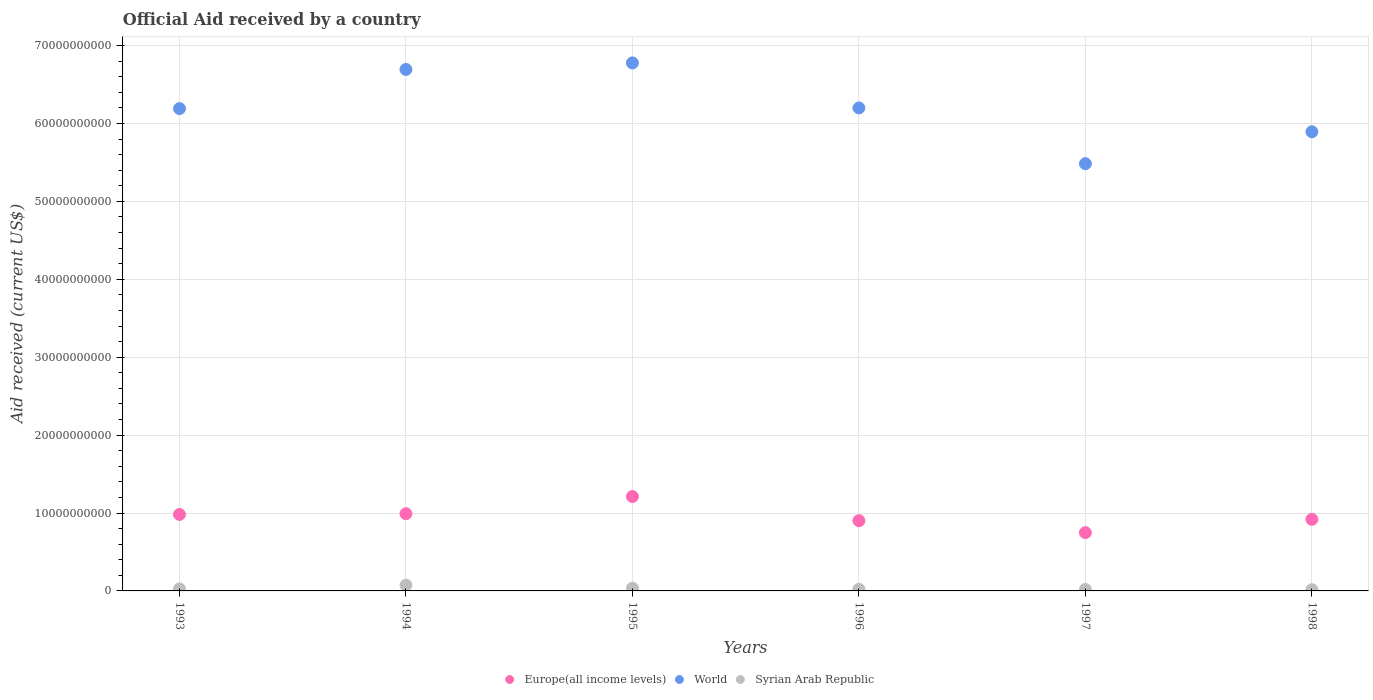What is the net official aid received in Europe(all income levels) in 1998?
Make the answer very short. 9.19e+09. Across all years, what is the maximum net official aid received in Syrian Arab Republic?
Your answer should be very brief. 7.44e+08. Across all years, what is the minimum net official aid received in World?
Give a very brief answer. 5.48e+1. What is the total net official aid received in Syrian Arab Republic in the graph?
Give a very brief answer. 1.93e+09. What is the difference between the net official aid received in World in 1993 and that in 1997?
Offer a very short reply. 7.07e+09. What is the difference between the net official aid received in Europe(all income levels) in 1993 and the net official aid received in World in 1994?
Your answer should be very brief. -5.71e+1. What is the average net official aid received in World per year?
Your answer should be very brief. 6.21e+1. In the year 1997, what is the difference between the net official aid received in World and net official aid received in Syrian Arab Republic?
Keep it short and to the point. 5.46e+1. What is the ratio of the net official aid received in World in 1993 to that in 1994?
Provide a short and direct response. 0.92. What is the difference between the highest and the second highest net official aid received in Syrian Arab Republic?
Provide a short and direct response. 3.88e+08. What is the difference between the highest and the lowest net official aid received in Europe(all income levels)?
Make the answer very short. 4.63e+09. Is it the case that in every year, the sum of the net official aid received in World and net official aid received in Europe(all income levels)  is greater than the net official aid received in Syrian Arab Republic?
Your answer should be compact. Yes. Does the net official aid received in Syrian Arab Republic monotonically increase over the years?
Your answer should be compact. No. Is the net official aid received in Europe(all income levels) strictly less than the net official aid received in World over the years?
Ensure brevity in your answer.  Yes. How many dotlines are there?
Offer a terse response. 3. What is the difference between two consecutive major ticks on the Y-axis?
Give a very brief answer. 1.00e+1. What is the title of the graph?
Your answer should be very brief. Official Aid received by a country. Does "Nigeria" appear as one of the legend labels in the graph?
Offer a very short reply. No. What is the label or title of the X-axis?
Ensure brevity in your answer.  Years. What is the label or title of the Y-axis?
Your answer should be compact. Aid received (current US$). What is the Aid received (current US$) of Europe(all income levels) in 1993?
Make the answer very short. 9.82e+09. What is the Aid received (current US$) of World in 1993?
Offer a very short reply. 6.19e+1. What is the Aid received (current US$) in Syrian Arab Republic in 1993?
Your response must be concise. 2.59e+08. What is the Aid received (current US$) of Europe(all income levels) in 1994?
Ensure brevity in your answer.  9.91e+09. What is the Aid received (current US$) in World in 1994?
Offer a terse response. 6.69e+1. What is the Aid received (current US$) in Syrian Arab Republic in 1994?
Your response must be concise. 7.44e+08. What is the Aid received (current US$) in Europe(all income levels) in 1995?
Keep it short and to the point. 1.21e+1. What is the Aid received (current US$) of World in 1995?
Ensure brevity in your answer.  6.78e+1. What is the Aid received (current US$) in Syrian Arab Republic in 1995?
Ensure brevity in your answer.  3.56e+08. What is the Aid received (current US$) of Europe(all income levels) in 1996?
Ensure brevity in your answer.  9.02e+09. What is the Aid received (current US$) in World in 1996?
Offer a terse response. 6.20e+1. What is the Aid received (current US$) in Syrian Arab Republic in 1996?
Provide a succinct answer. 2.16e+08. What is the Aid received (current US$) of Europe(all income levels) in 1997?
Ensure brevity in your answer.  7.48e+09. What is the Aid received (current US$) in World in 1997?
Keep it short and to the point. 5.48e+1. What is the Aid received (current US$) of Syrian Arab Republic in 1997?
Offer a terse response. 1.97e+08. What is the Aid received (current US$) in Europe(all income levels) in 1998?
Provide a succinct answer. 9.19e+09. What is the Aid received (current US$) of World in 1998?
Offer a very short reply. 5.89e+1. What is the Aid received (current US$) of Syrian Arab Republic in 1998?
Provide a succinct answer. 1.55e+08. Across all years, what is the maximum Aid received (current US$) in Europe(all income levels)?
Make the answer very short. 1.21e+1. Across all years, what is the maximum Aid received (current US$) of World?
Your response must be concise. 6.78e+1. Across all years, what is the maximum Aid received (current US$) in Syrian Arab Republic?
Offer a very short reply. 7.44e+08. Across all years, what is the minimum Aid received (current US$) in Europe(all income levels)?
Your answer should be compact. 7.48e+09. Across all years, what is the minimum Aid received (current US$) in World?
Provide a short and direct response. 5.48e+1. Across all years, what is the minimum Aid received (current US$) of Syrian Arab Republic?
Your response must be concise. 1.55e+08. What is the total Aid received (current US$) of Europe(all income levels) in the graph?
Provide a succinct answer. 5.75e+1. What is the total Aid received (current US$) in World in the graph?
Offer a terse response. 3.72e+11. What is the total Aid received (current US$) in Syrian Arab Republic in the graph?
Provide a succinct answer. 1.93e+09. What is the difference between the Aid received (current US$) in Europe(all income levels) in 1993 and that in 1994?
Offer a very short reply. -9.28e+07. What is the difference between the Aid received (current US$) of World in 1993 and that in 1994?
Make the answer very short. -5.03e+09. What is the difference between the Aid received (current US$) in Syrian Arab Republic in 1993 and that in 1994?
Give a very brief answer. -4.85e+08. What is the difference between the Aid received (current US$) in Europe(all income levels) in 1993 and that in 1995?
Your answer should be very brief. -2.29e+09. What is the difference between the Aid received (current US$) of World in 1993 and that in 1995?
Make the answer very short. -5.87e+09. What is the difference between the Aid received (current US$) in Syrian Arab Republic in 1993 and that in 1995?
Offer a very short reply. -9.74e+07. What is the difference between the Aid received (current US$) of Europe(all income levels) in 1993 and that in 1996?
Give a very brief answer. 8.02e+08. What is the difference between the Aid received (current US$) in World in 1993 and that in 1996?
Give a very brief answer. -9.08e+07. What is the difference between the Aid received (current US$) of Syrian Arab Republic in 1993 and that in 1996?
Your answer should be compact. 4.26e+07. What is the difference between the Aid received (current US$) in Europe(all income levels) in 1993 and that in 1997?
Your answer should be compact. 2.34e+09. What is the difference between the Aid received (current US$) in World in 1993 and that in 1997?
Keep it short and to the point. 7.07e+09. What is the difference between the Aid received (current US$) in Syrian Arab Republic in 1993 and that in 1997?
Offer a terse response. 6.19e+07. What is the difference between the Aid received (current US$) of Europe(all income levels) in 1993 and that in 1998?
Ensure brevity in your answer.  6.27e+08. What is the difference between the Aid received (current US$) of World in 1993 and that in 1998?
Your answer should be compact. 2.97e+09. What is the difference between the Aid received (current US$) of Syrian Arab Republic in 1993 and that in 1998?
Your response must be concise. 1.03e+08. What is the difference between the Aid received (current US$) of Europe(all income levels) in 1994 and that in 1995?
Provide a succinct answer. -2.20e+09. What is the difference between the Aid received (current US$) in World in 1994 and that in 1995?
Provide a succinct answer. -8.36e+08. What is the difference between the Aid received (current US$) of Syrian Arab Republic in 1994 and that in 1995?
Provide a short and direct response. 3.88e+08. What is the difference between the Aid received (current US$) in Europe(all income levels) in 1994 and that in 1996?
Give a very brief answer. 8.95e+08. What is the difference between the Aid received (current US$) in World in 1994 and that in 1996?
Make the answer very short. 4.94e+09. What is the difference between the Aid received (current US$) in Syrian Arab Republic in 1994 and that in 1996?
Your response must be concise. 5.28e+08. What is the difference between the Aid received (current US$) of Europe(all income levels) in 1994 and that in 1997?
Your answer should be very brief. 2.43e+09. What is the difference between the Aid received (current US$) in World in 1994 and that in 1997?
Ensure brevity in your answer.  1.21e+1. What is the difference between the Aid received (current US$) of Syrian Arab Republic in 1994 and that in 1997?
Make the answer very short. 5.47e+08. What is the difference between the Aid received (current US$) of Europe(all income levels) in 1994 and that in 1998?
Your answer should be compact. 7.20e+08. What is the difference between the Aid received (current US$) in World in 1994 and that in 1998?
Provide a short and direct response. 8.00e+09. What is the difference between the Aid received (current US$) in Syrian Arab Republic in 1994 and that in 1998?
Give a very brief answer. 5.89e+08. What is the difference between the Aid received (current US$) of Europe(all income levels) in 1995 and that in 1996?
Your response must be concise. 3.09e+09. What is the difference between the Aid received (current US$) of World in 1995 and that in 1996?
Keep it short and to the point. 5.78e+09. What is the difference between the Aid received (current US$) in Syrian Arab Republic in 1995 and that in 1996?
Keep it short and to the point. 1.40e+08. What is the difference between the Aid received (current US$) in Europe(all income levels) in 1995 and that in 1997?
Provide a short and direct response. 4.63e+09. What is the difference between the Aid received (current US$) in World in 1995 and that in 1997?
Make the answer very short. 1.29e+1. What is the difference between the Aid received (current US$) of Syrian Arab Republic in 1995 and that in 1997?
Your response must be concise. 1.59e+08. What is the difference between the Aid received (current US$) in Europe(all income levels) in 1995 and that in 1998?
Keep it short and to the point. 2.92e+09. What is the difference between the Aid received (current US$) of World in 1995 and that in 1998?
Offer a terse response. 8.84e+09. What is the difference between the Aid received (current US$) in Syrian Arab Republic in 1995 and that in 1998?
Offer a very short reply. 2.01e+08. What is the difference between the Aid received (current US$) of Europe(all income levels) in 1996 and that in 1997?
Offer a terse response. 1.53e+09. What is the difference between the Aid received (current US$) in World in 1996 and that in 1997?
Your response must be concise. 7.16e+09. What is the difference between the Aid received (current US$) of Syrian Arab Republic in 1996 and that in 1997?
Make the answer very short. 1.93e+07. What is the difference between the Aid received (current US$) in Europe(all income levels) in 1996 and that in 1998?
Provide a succinct answer. -1.75e+08. What is the difference between the Aid received (current US$) in World in 1996 and that in 1998?
Make the answer very short. 3.06e+09. What is the difference between the Aid received (current US$) of Syrian Arab Republic in 1996 and that in 1998?
Your response must be concise. 6.08e+07. What is the difference between the Aid received (current US$) in Europe(all income levels) in 1997 and that in 1998?
Your response must be concise. -1.71e+09. What is the difference between the Aid received (current US$) in World in 1997 and that in 1998?
Give a very brief answer. -4.10e+09. What is the difference between the Aid received (current US$) of Syrian Arab Republic in 1997 and that in 1998?
Provide a succinct answer. 4.16e+07. What is the difference between the Aid received (current US$) of Europe(all income levels) in 1993 and the Aid received (current US$) of World in 1994?
Ensure brevity in your answer.  -5.71e+1. What is the difference between the Aid received (current US$) in Europe(all income levels) in 1993 and the Aid received (current US$) in Syrian Arab Republic in 1994?
Your answer should be compact. 9.07e+09. What is the difference between the Aid received (current US$) of World in 1993 and the Aid received (current US$) of Syrian Arab Republic in 1994?
Give a very brief answer. 6.12e+1. What is the difference between the Aid received (current US$) of Europe(all income levels) in 1993 and the Aid received (current US$) of World in 1995?
Offer a very short reply. -5.80e+1. What is the difference between the Aid received (current US$) in Europe(all income levels) in 1993 and the Aid received (current US$) in Syrian Arab Republic in 1995?
Keep it short and to the point. 9.46e+09. What is the difference between the Aid received (current US$) of World in 1993 and the Aid received (current US$) of Syrian Arab Republic in 1995?
Offer a very short reply. 6.16e+1. What is the difference between the Aid received (current US$) of Europe(all income levels) in 1993 and the Aid received (current US$) of World in 1996?
Provide a short and direct response. -5.22e+1. What is the difference between the Aid received (current US$) in Europe(all income levels) in 1993 and the Aid received (current US$) in Syrian Arab Republic in 1996?
Make the answer very short. 9.60e+09. What is the difference between the Aid received (current US$) of World in 1993 and the Aid received (current US$) of Syrian Arab Republic in 1996?
Your answer should be very brief. 6.17e+1. What is the difference between the Aid received (current US$) in Europe(all income levels) in 1993 and the Aid received (current US$) in World in 1997?
Keep it short and to the point. -4.50e+1. What is the difference between the Aid received (current US$) in Europe(all income levels) in 1993 and the Aid received (current US$) in Syrian Arab Republic in 1997?
Provide a short and direct response. 9.62e+09. What is the difference between the Aid received (current US$) of World in 1993 and the Aid received (current US$) of Syrian Arab Republic in 1997?
Your answer should be compact. 6.17e+1. What is the difference between the Aid received (current US$) in Europe(all income levels) in 1993 and the Aid received (current US$) in World in 1998?
Keep it short and to the point. -4.91e+1. What is the difference between the Aid received (current US$) of Europe(all income levels) in 1993 and the Aid received (current US$) of Syrian Arab Republic in 1998?
Keep it short and to the point. 9.66e+09. What is the difference between the Aid received (current US$) of World in 1993 and the Aid received (current US$) of Syrian Arab Republic in 1998?
Give a very brief answer. 6.18e+1. What is the difference between the Aid received (current US$) of Europe(all income levels) in 1994 and the Aid received (current US$) of World in 1995?
Your answer should be compact. -5.79e+1. What is the difference between the Aid received (current US$) of Europe(all income levels) in 1994 and the Aid received (current US$) of Syrian Arab Republic in 1995?
Your response must be concise. 9.56e+09. What is the difference between the Aid received (current US$) of World in 1994 and the Aid received (current US$) of Syrian Arab Republic in 1995?
Give a very brief answer. 6.66e+1. What is the difference between the Aid received (current US$) of Europe(all income levels) in 1994 and the Aid received (current US$) of World in 1996?
Your response must be concise. -5.21e+1. What is the difference between the Aid received (current US$) in Europe(all income levels) in 1994 and the Aid received (current US$) in Syrian Arab Republic in 1996?
Ensure brevity in your answer.  9.70e+09. What is the difference between the Aid received (current US$) in World in 1994 and the Aid received (current US$) in Syrian Arab Republic in 1996?
Your answer should be very brief. 6.67e+1. What is the difference between the Aid received (current US$) in Europe(all income levels) in 1994 and the Aid received (current US$) in World in 1997?
Keep it short and to the point. -4.49e+1. What is the difference between the Aid received (current US$) in Europe(all income levels) in 1994 and the Aid received (current US$) in Syrian Arab Republic in 1997?
Offer a very short reply. 9.71e+09. What is the difference between the Aid received (current US$) of World in 1994 and the Aid received (current US$) of Syrian Arab Republic in 1997?
Ensure brevity in your answer.  6.67e+1. What is the difference between the Aid received (current US$) of Europe(all income levels) in 1994 and the Aid received (current US$) of World in 1998?
Offer a very short reply. -4.90e+1. What is the difference between the Aid received (current US$) of Europe(all income levels) in 1994 and the Aid received (current US$) of Syrian Arab Republic in 1998?
Your answer should be very brief. 9.76e+09. What is the difference between the Aid received (current US$) of World in 1994 and the Aid received (current US$) of Syrian Arab Republic in 1998?
Your answer should be compact. 6.68e+1. What is the difference between the Aid received (current US$) in Europe(all income levels) in 1995 and the Aid received (current US$) in World in 1996?
Your answer should be compact. -4.99e+1. What is the difference between the Aid received (current US$) in Europe(all income levels) in 1995 and the Aid received (current US$) in Syrian Arab Republic in 1996?
Your answer should be compact. 1.19e+1. What is the difference between the Aid received (current US$) of World in 1995 and the Aid received (current US$) of Syrian Arab Republic in 1996?
Provide a short and direct response. 6.76e+1. What is the difference between the Aid received (current US$) of Europe(all income levels) in 1995 and the Aid received (current US$) of World in 1997?
Offer a very short reply. -4.27e+1. What is the difference between the Aid received (current US$) of Europe(all income levels) in 1995 and the Aid received (current US$) of Syrian Arab Republic in 1997?
Make the answer very short. 1.19e+1. What is the difference between the Aid received (current US$) of World in 1995 and the Aid received (current US$) of Syrian Arab Republic in 1997?
Give a very brief answer. 6.76e+1. What is the difference between the Aid received (current US$) in Europe(all income levels) in 1995 and the Aid received (current US$) in World in 1998?
Provide a short and direct response. -4.68e+1. What is the difference between the Aid received (current US$) of Europe(all income levels) in 1995 and the Aid received (current US$) of Syrian Arab Republic in 1998?
Ensure brevity in your answer.  1.20e+1. What is the difference between the Aid received (current US$) of World in 1995 and the Aid received (current US$) of Syrian Arab Republic in 1998?
Offer a terse response. 6.76e+1. What is the difference between the Aid received (current US$) in Europe(all income levels) in 1996 and the Aid received (current US$) in World in 1997?
Your response must be concise. -4.58e+1. What is the difference between the Aid received (current US$) of Europe(all income levels) in 1996 and the Aid received (current US$) of Syrian Arab Republic in 1997?
Your response must be concise. 8.82e+09. What is the difference between the Aid received (current US$) in World in 1996 and the Aid received (current US$) in Syrian Arab Republic in 1997?
Offer a very short reply. 6.18e+1. What is the difference between the Aid received (current US$) of Europe(all income levels) in 1996 and the Aid received (current US$) of World in 1998?
Your response must be concise. -4.99e+1. What is the difference between the Aid received (current US$) of Europe(all income levels) in 1996 and the Aid received (current US$) of Syrian Arab Republic in 1998?
Offer a terse response. 8.86e+09. What is the difference between the Aid received (current US$) of World in 1996 and the Aid received (current US$) of Syrian Arab Republic in 1998?
Your response must be concise. 6.18e+1. What is the difference between the Aid received (current US$) in Europe(all income levels) in 1997 and the Aid received (current US$) in World in 1998?
Provide a succinct answer. -5.15e+1. What is the difference between the Aid received (current US$) in Europe(all income levels) in 1997 and the Aid received (current US$) in Syrian Arab Republic in 1998?
Offer a very short reply. 7.33e+09. What is the difference between the Aid received (current US$) in World in 1997 and the Aid received (current US$) in Syrian Arab Republic in 1998?
Your answer should be very brief. 5.47e+1. What is the average Aid received (current US$) of Europe(all income levels) per year?
Your answer should be compact. 9.59e+09. What is the average Aid received (current US$) in World per year?
Your response must be concise. 6.21e+1. What is the average Aid received (current US$) in Syrian Arab Republic per year?
Ensure brevity in your answer.  3.21e+08. In the year 1993, what is the difference between the Aid received (current US$) in Europe(all income levels) and Aid received (current US$) in World?
Your response must be concise. -5.21e+1. In the year 1993, what is the difference between the Aid received (current US$) of Europe(all income levels) and Aid received (current US$) of Syrian Arab Republic?
Ensure brevity in your answer.  9.56e+09. In the year 1993, what is the difference between the Aid received (current US$) of World and Aid received (current US$) of Syrian Arab Republic?
Give a very brief answer. 6.17e+1. In the year 1994, what is the difference between the Aid received (current US$) in Europe(all income levels) and Aid received (current US$) in World?
Make the answer very short. -5.70e+1. In the year 1994, what is the difference between the Aid received (current US$) of Europe(all income levels) and Aid received (current US$) of Syrian Arab Republic?
Ensure brevity in your answer.  9.17e+09. In the year 1994, what is the difference between the Aid received (current US$) in World and Aid received (current US$) in Syrian Arab Republic?
Ensure brevity in your answer.  6.62e+1. In the year 1995, what is the difference between the Aid received (current US$) of Europe(all income levels) and Aid received (current US$) of World?
Give a very brief answer. -5.57e+1. In the year 1995, what is the difference between the Aid received (current US$) in Europe(all income levels) and Aid received (current US$) in Syrian Arab Republic?
Provide a succinct answer. 1.18e+1. In the year 1995, what is the difference between the Aid received (current US$) of World and Aid received (current US$) of Syrian Arab Republic?
Your answer should be very brief. 6.74e+1. In the year 1996, what is the difference between the Aid received (current US$) in Europe(all income levels) and Aid received (current US$) in World?
Keep it short and to the point. -5.30e+1. In the year 1996, what is the difference between the Aid received (current US$) in Europe(all income levels) and Aid received (current US$) in Syrian Arab Republic?
Your response must be concise. 8.80e+09. In the year 1996, what is the difference between the Aid received (current US$) in World and Aid received (current US$) in Syrian Arab Republic?
Your answer should be very brief. 6.18e+1. In the year 1997, what is the difference between the Aid received (current US$) of Europe(all income levels) and Aid received (current US$) of World?
Provide a short and direct response. -4.74e+1. In the year 1997, what is the difference between the Aid received (current US$) of Europe(all income levels) and Aid received (current US$) of Syrian Arab Republic?
Make the answer very short. 7.29e+09. In the year 1997, what is the difference between the Aid received (current US$) of World and Aid received (current US$) of Syrian Arab Republic?
Give a very brief answer. 5.46e+1. In the year 1998, what is the difference between the Aid received (current US$) of Europe(all income levels) and Aid received (current US$) of World?
Provide a short and direct response. -4.97e+1. In the year 1998, what is the difference between the Aid received (current US$) in Europe(all income levels) and Aid received (current US$) in Syrian Arab Republic?
Offer a very short reply. 9.04e+09. In the year 1998, what is the difference between the Aid received (current US$) in World and Aid received (current US$) in Syrian Arab Republic?
Your answer should be very brief. 5.88e+1. What is the ratio of the Aid received (current US$) of Europe(all income levels) in 1993 to that in 1994?
Keep it short and to the point. 0.99. What is the ratio of the Aid received (current US$) of World in 1993 to that in 1994?
Give a very brief answer. 0.92. What is the ratio of the Aid received (current US$) of Syrian Arab Republic in 1993 to that in 1994?
Make the answer very short. 0.35. What is the ratio of the Aid received (current US$) in Europe(all income levels) in 1993 to that in 1995?
Provide a short and direct response. 0.81. What is the ratio of the Aid received (current US$) of World in 1993 to that in 1995?
Keep it short and to the point. 0.91. What is the ratio of the Aid received (current US$) of Syrian Arab Republic in 1993 to that in 1995?
Keep it short and to the point. 0.73. What is the ratio of the Aid received (current US$) in Europe(all income levels) in 1993 to that in 1996?
Your answer should be very brief. 1.09. What is the ratio of the Aid received (current US$) in Syrian Arab Republic in 1993 to that in 1996?
Offer a terse response. 1.2. What is the ratio of the Aid received (current US$) in Europe(all income levels) in 1993 to that in 1997?
Provide a short and direct response. 1.31. What is the ratio of the Aid received (current US$) of World in 1993 to that in 1997?
Your answer should be very brief. 1.13. What is the ratio of the Aid received (current US$) of Syrian Arab Republic in 1993 to that in 1997?
Make the answer very short. 1.31. What is the ratio of the Aid received (current US$) in Europe(all income levels) in 1993 to that in 1998?
Provide a succinct answer. 1.07. What is the ratio of the Aid received (current US$) of World in 1993 to that in 1998?
Offer a terse response. 1.05. What is the ratio of the Aid received (current US$) in Syrian Arab Republic in 1993 to that in 1998?
Your response must be concise. 1.67. What is the ratio of the Aid received (current US$) of Europe(all income levels) in 1994 to that in 1995?
Offer a terse response. 0.82. What is the ratio of the Aid received (current US$) of World in 1994 to that in 1995?
Ensure brevity in your answer.  0.99. What is the ratio of the Aid received (current US$) in Syrian Arab Republic in 1994 to that in 1995?
Your response must be concise. 2.09. What is the ratio of the Aid received (current US$) of Europe(all income levels) in 1994 to that in 1996?
Your answer should be very brief. 1.1. What is the ratio of the Aid received (current US$) in World in 1994 to that in 1996?
Offer a very short reply. 1.08. What is the ratio of the Aid received (current US$) in Syrian Arab Republic in 1994 to that in 1996?
Give a very brief answer. 3.44. What is the ratio of the Aid received (current US$) in Europe(all income levels) in 1994 to that in 1997?
Keep it short and to the point. 1.32. What is the ratio of the Aid received (current US$) of World in 1994 to that in 1997?
Offer a very short reply. 1.22. What is the ratio of the Aid received (current US$) of Syrian Arab Republic in 1994 to that in 1997?
Provide a succinct answer. 3.78. What is the ratio of the Aid received (current US$) in Europe(all income levels) in 1994 to that in 1998?
Provide a short and direct response. 1.08. What is the ratio of the Aid received (current US$) in World in 1994 to that in 1998?
Provide a short and direct response. 1.14. What is the ratio of the Aid received (current US$) of Syrian Arab Republic in 1994 to that in 1998?
Give a very brief answer. 4.8. What is the ratio of the Aid received (current US$) in Europe(all income levels) in 1995 to that in 1996?
Your answer should be compact. 1.34. What is the ratio of the Aid received (current US$) of World in 1995 to that in 1996?
Provide a succinct answer. 1.09. What is the ratio of the Aid received (current US$) in Syrian Arab Republic in 1995 to that in 1996?
Provide a short and direct response. 1.65. What is the ratio of the Aid received (current US$) in Europe(all income levels) in 1995 to that in 1997?
Give a very brief answer. 1.62. What is the ratio of the Aid received (current US$) of World in 1995 to that in 1997?
Keep it short and to the point. 1.24. What is the ratio of the Aid received (current US$) of Syrian Arab Republic in 1995 to that in 1997?
Give a very brief answer. 1.81. What is the ratio of the Aid received (current US$) of Europe(all income levels) in 1995 to that in 1998?
Make the answer very short. 1.32. What is the ratio of the Aid received (current US$) of World in 1995 to that in 1998?
Provide a short and direct response. 1.15. What is the ratio of the Aid received (current US$) in Syrian Arab Republic in 1995 to that in 1998?
Give a very brief answer. 2.29. What is the ratio of the Aid received (current US$) of Europe(all income levels) in 1996 to that in 1997?
Provide a succinct answer. 1.2. What is the ratio of the Aid received (current US$) in World in 1996 to that in 1997?
Provide a succinct answer. 1.13. What is the ratio of the Aid received (current US$) in Syrian Arab Republic in 1996 to that in 1997?
Give a very brief answer. 1.1. What is the ratio of the Aid received (current US$) of Europe(all income levels) in 1996 to that in 1998?
Offer a very short reply. 0.98. What is the ratio of the Aid received (current US$) of World in 1996 to that in 1998?
Offer a terse response. 1.05. What is the ratio of the Aid received (current US$) of Syrian Arab Republic in 1996 to that in 1998?
Provide a succinct answer. 1.39. What is the ratio of the Aid received (current US$) of Europe(all income levels) in 1997 to that in 1998?
Ensure brevity in your answer.  0.81. What is the ratio of the Aid received (current US$) of World in 1997 to that in 1998?
Keep it short and to the point. 0.93. What is the ratio of the Aid received (current US$) in Syrian Arab Republic in 1997 to that in 1998?
Give a very brief answer. 1.27. What is the difference between the highest and the second highest Aid received (current US$) in Europe(all income levels)?
Offer a very short reply. 2.20e+09. What is the difference between the highest and the second highest Aid received (current US$) in World?
Your answer should be compact. 8.36e+08. What is the difference between the highest and the second highest Aid received (current US$) of Syrian Arab Republic?
Keep it short and to the point. 3.88e+08. What is the difference between the highest and the lowest Aid received (current US$) of Europe(all income levels)?
Make the answer very short. 4.63e+09. What is the difference between the highest and the lowest Aid received (current US$) of World?
Provide a succinct answer. 1.29e+1. What is the difference between the highest and the lowest Aid received (current US$) of Syrian Arab Republic?
Provide a short and direct response. 5.89e+08. 